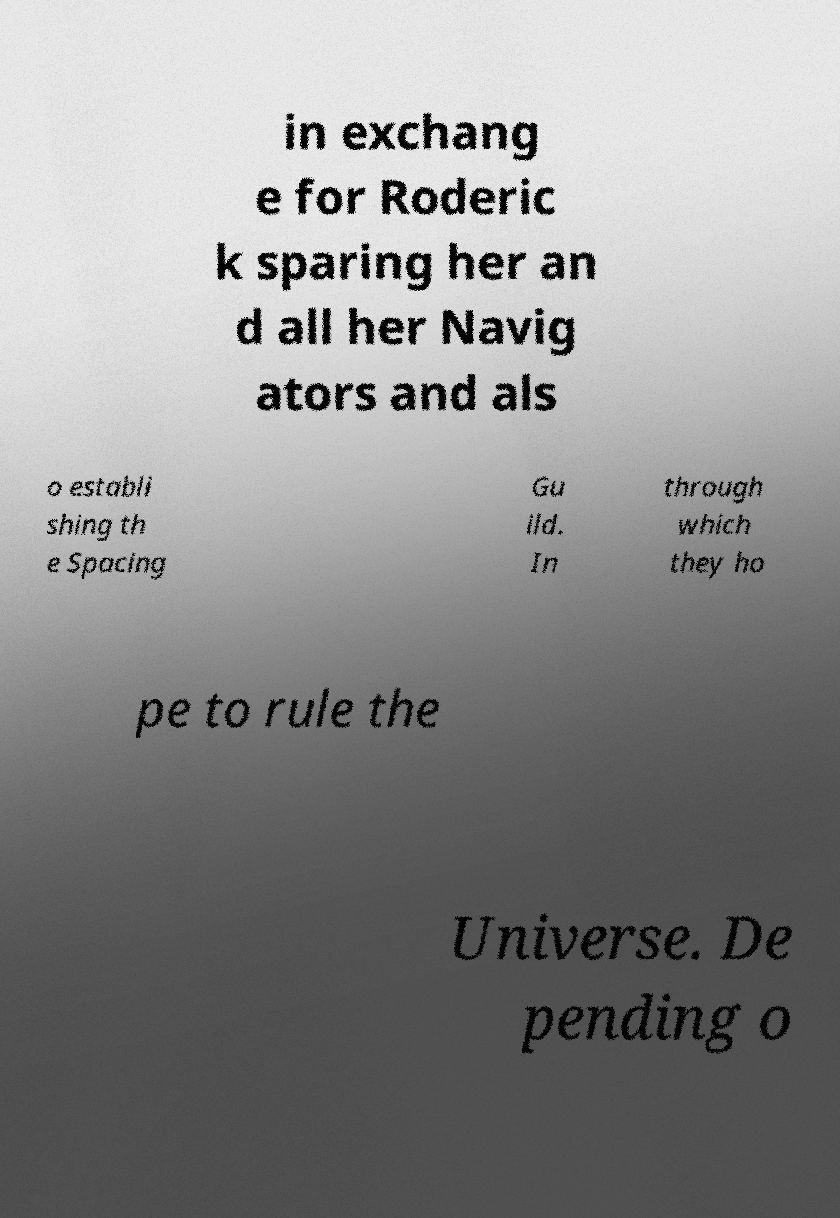Please read and relay the text visible in this image. What does it say? in exchang e for Roderic k sparing her an d all her Navig ators and als o establi shing th e Spacing Gu ild. In through which they ho pe to rule the Universe. De pending o 